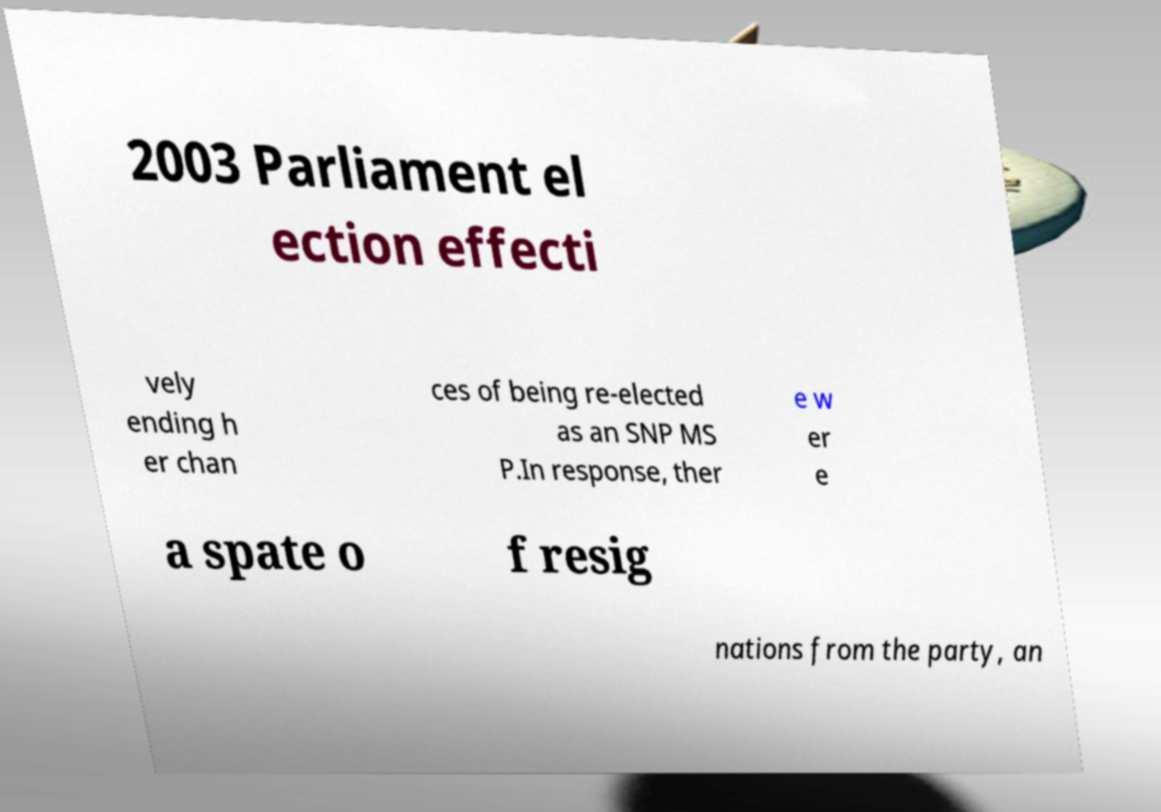I need the written content from this picture converted into text. Can you do that? 2003 Parliament el ection effecti vely ending h er chan ces of being re-elected as an SNP MS P.In response, ther e w er e a spate o f resig nations from the party, an 